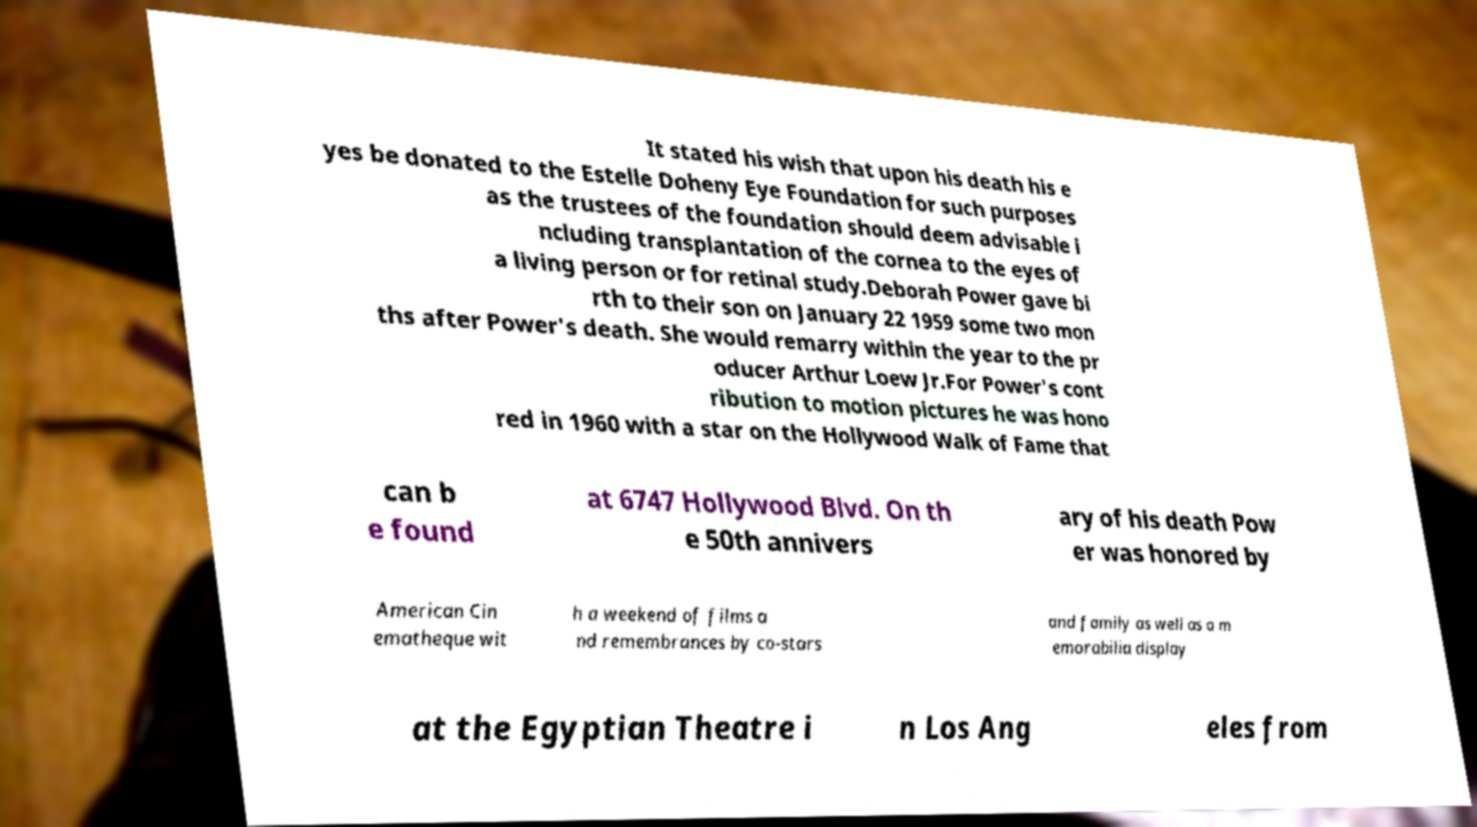For documentation purposes, I need the text within this image transcribed. Could you provide that? It stated his wish that upon his death his e yes be donated to the Estelle Doheny Eye Foundation for such purposes as the trustees of the foundation should deem advisable i ncluding transplantation of the cornea to the eyes of a living person or for retinal study.Deborah Power gave bi rth to their son on January 22 1959 some two mon ths after Power's death. She would remarry within the year to the pr oducer Arthur Loew Jr.For Power's cont ribution to motion pictures he was hono red in 1960 with a star on the Hollywood Walk of Fame that can b e found at 6747 Hollywood Blvd. On th e 50th annivers ary of his death Pow er was honored by American Cin ematheque wit h a weekend of films a nd remembrances by co-stars and family as well as a m emorabilia display at the Egyptian Theatre i n Los Ang eles from 